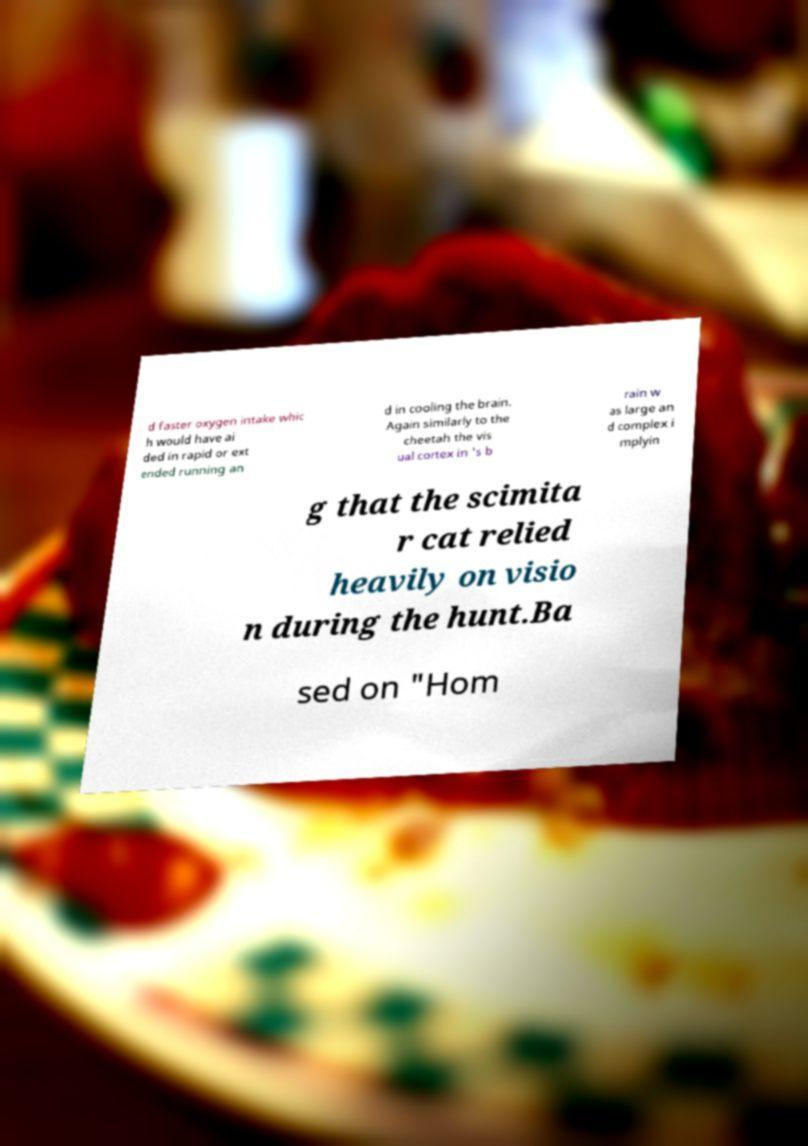Please identify and transcribe the text found in this image. d faster oxygen intake whic h would have ai ded in rapid or ext ended running an d in cooling the brain. Again similarly to the cheetah the vis ual cortex in 's b rain w as large an d complex i mplyin g that the scimita r cat relied heavily on visio n during the hunt.Ba sed on "Hom 